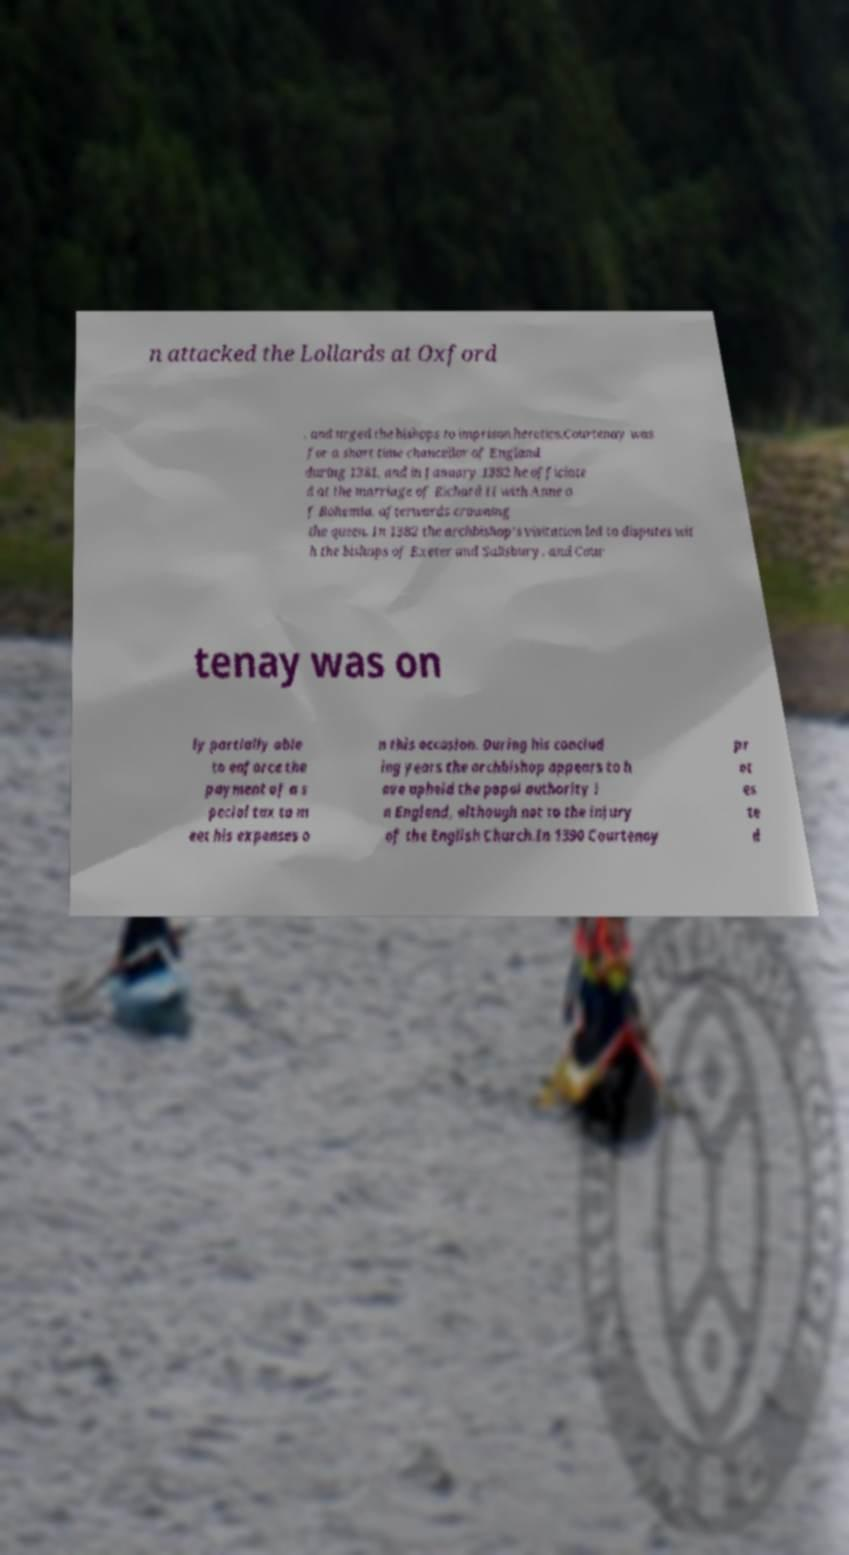Can you read and provide the text displayed in the image?This photo seems to have some interesting text. Can you extract and type it out for me? n attacked the Lollards at Oxford , and urged the bishops to imprison heretics.Courtenay was for a short time chancellor of England during 1381, and in January 1382 he officiate d at the marriage of Richard II with Anne o f Bohemia, afterwards crowning the queen. In 1382 the archbishop's visitation led to disputes wit h the bishops of Exeter and Salisbury, and Cour tenay was on ly partially able to enforce the payment of a s pecial tax to m eet his expenses o n this occasion. During his conclud ing years the archbishop appears to h ave upheld the papal authority i n England, although not to the injury of the English Church.In 1390 Courtenay pr ot es te d 